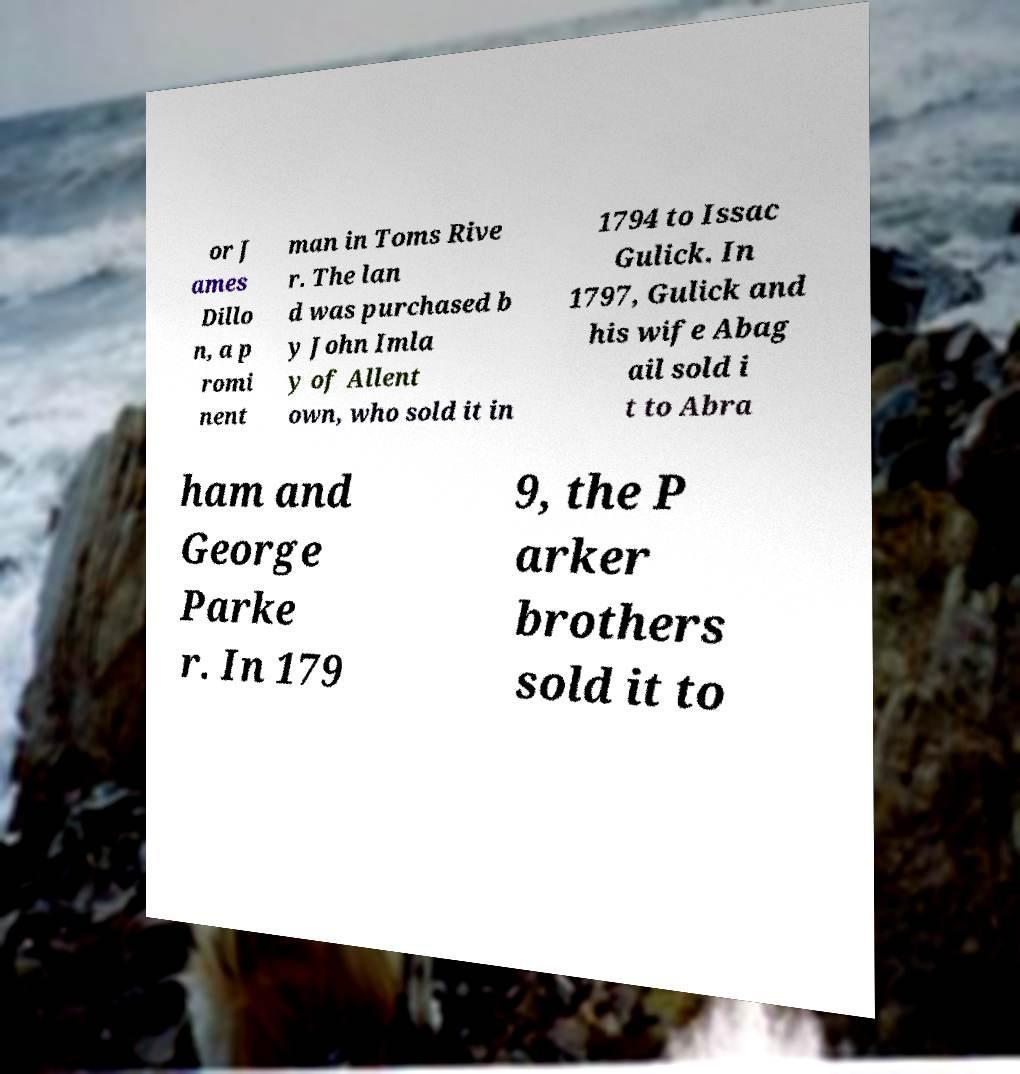Please identify and transcribe the text found in this image. or J ames Dillo n, a p romi nent man in Toms Rive r. The lan d was purchased b y John Imla y of Allent own, who sold it in 1794 to Issac Gulick. In 1797, Gulick and his wife Abag ail sold i t to Abra ham and George Parke r. In 179 9, the P arker brothers sold it to 